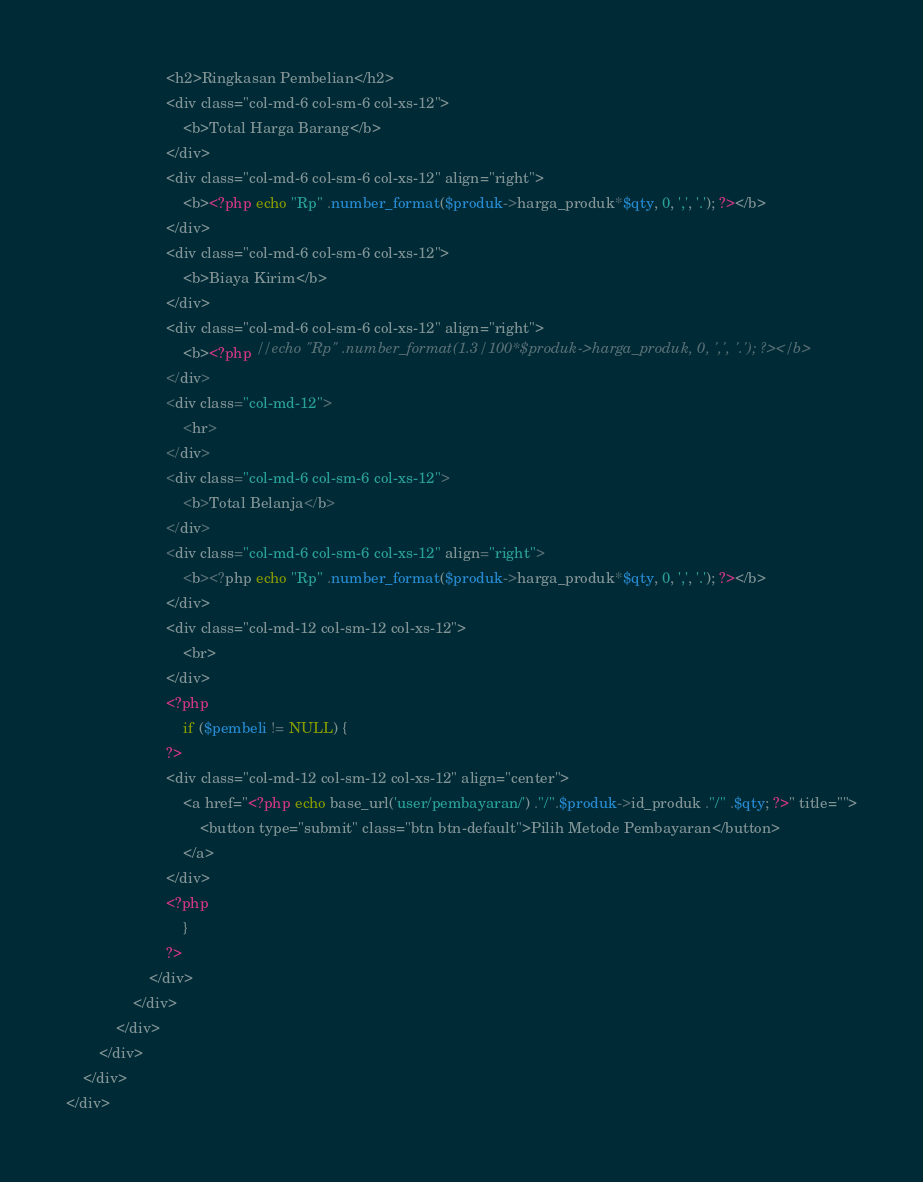Convert code to text. <code><loc_0><loc_0><loc_500><loc_500><_PHP_>						<h2>Ringkasan Pembelian</h2>
						<div class="col-md-6 col-sm-6 col-xs-12">
							<b>Total Harga Barang</b>
						</div>
						<div class="col-md-6 col-sm-6 col-xs-12" align="right">
							<b><?php echo "Rp" .number_format($produk->harga_produk*$qty, 0, ',', '.'); ?></b>
						</div>
						<div class="col-md-6 col-sm-6 col-xs-12">
							<b>Biaya Kirim</b>
						</div>
						<div class="col-md-6 col-sm-6 col-xs-12" align="right">
							<b><?php //echo "Rp" .number_format(1.3/100*$produk->harga_produk, 0, ',', '.'); ?></b>
						</div>
						<div class="col-md-12">
							<hr>
						</div>
						<div class="col-md-6 col-sm-6 col-xs-12">
							<b>Total Belanja</b>
						</div>
						<div class="col-md-6 col-sm-6 col-xs-12" align="right">
							<b><?php echo "Rp" .number_format($produk->harga_produk*$qty, 0, ',', '.'); ?></b>
						</div>
						<div class="col-md-12 col-sm-12 col-xs-12">
							<br>
						</div>
						<?php
							if ($pembeli != NULL) {
						?>
						<div class="col-md-12 col-sm-12 col-xs-12" align="center">
							<a href="<?php echo base_url('user/pembayaran/') ."/".$produk->id_produk ."/" .$qty; ?>" title="">
								<button type="submit" class="btn btn-default">Pilih Metode Pembayaran</button>
							</a>
						</div>
						<?php
							}
						?>
					</div>
				</div>
			</div>
		</div>
	</div>
</div></code> 